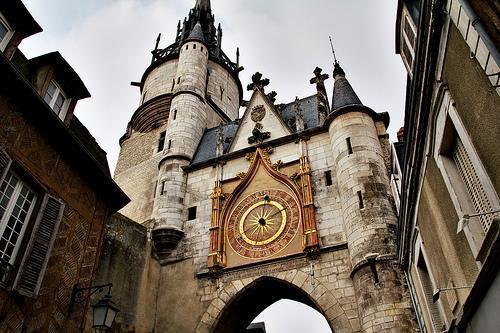How many arrow slits are on the right tower?
Give a very brief answer. 3. How many buildings are made of pudding?
Give a very brief answer. 0. 